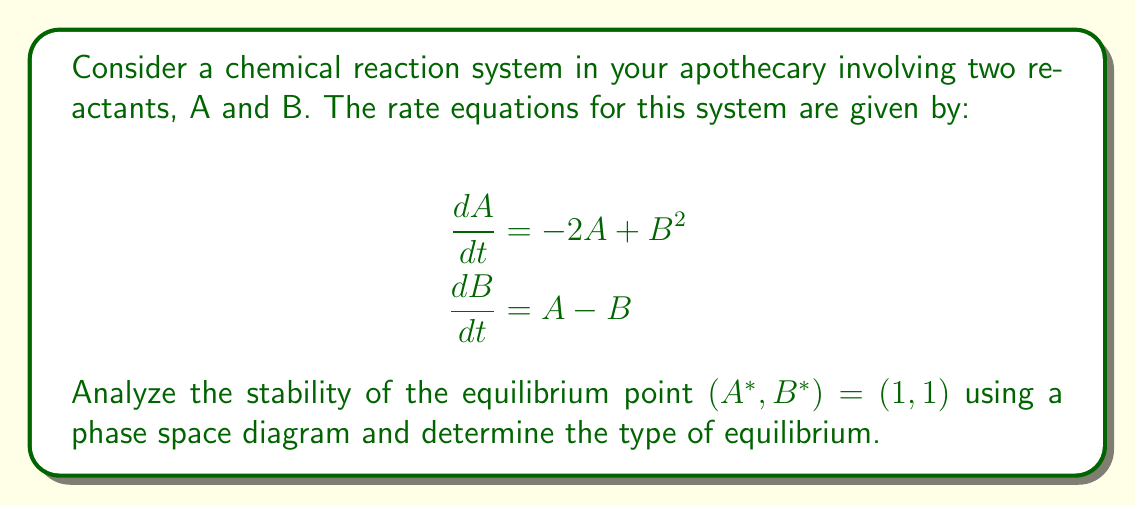Could you help me with this problem? 1. First, we need to find the Jacobian matrix of the system at the equilibrium point:

   $$J = \begin{bmatrix}
   \frac{\partial}{\partial A}(-2A + B^2) & \frac{\partial}{\partial B}(-2A + B^2) \\
   \frac{\partial}{\partial A}(A - B) & \frac{\partial}{\partial B}(A - B)
   \end{bmatrix} = \begin{bmatrix}
   -2 & 2B \\
   1 & -1
   \end{bmatrix}$$

2. Evaluate the Jacobian at the equilibrium point (1, 1):

   $$J_{(1,1)} = \begin{bmatrix}
   -2 & 2 \\
   1 & -1
   \end{bmatrix}$$

3. Calculate the eigenvalues of $J_{(1,1)}$:

   $$\det(J_{(1,1)} - \lambda I) = \begin{vmatrix}
   -2-\lambda & 2 \\
   1 & -1-\lambda
   \end{vmatrix} = \lambda^2 + 3\lambda + 1 = 0$$

   Solving this quadratic equation:
   $$\lambda = \frac{-3 \pm \sqrt{9-4}}{2} = \frac{-3 \pm \sqrt{5}}{2}$$

4. The eigenvalues are:
   $$\lambda_1 = \frac{-3 + \sqrt{5}}{2} \approx -0.382$$
   $$\lambda_2 = \frac{-3 - \sqrt{5}}{2} \approx -2.618$$

5. Both eigenvalues are real and negative, which indicates that the equilibrium point is a stable node.

6. To visualize this, we can sketch a phase space diagram:

   [asy]
   import graph;
   size(200,200);
   
   void vector(pair z, pair v) {
     draw(z--z+v, arrow=Arrow(TeXHead));
   }
   
   for(int i=-2; i<=4; ++i) {
     for(int j=-2; j<=4; ++j) {
       pair z=(i,j);
       pair v=(-2*i+j*j, i-j);
       vector(z, 0.2*unit(v));
     }
   }
   
   dot((1,1));
   label("(1,1)", (1,1), SE);
   
   xaxis("A", arrow=Arrow);
   yaxis("B", arrow=Arrow);
   [/asy]

   The phase space diagram shows that all trajectories converge to the equilibrium point (1,1), confirming it is a stable node.
Answer: Stable node 